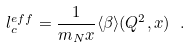Convert formula to latex. <formula><loc_0><loc_0><loc_500><loc_500>l _ { c } ^ { e f f } = \frac { 1 } { m _ { N } x } \langle \beta \rangle ( Q ^ { 2 } , x ) \ .</formula> 